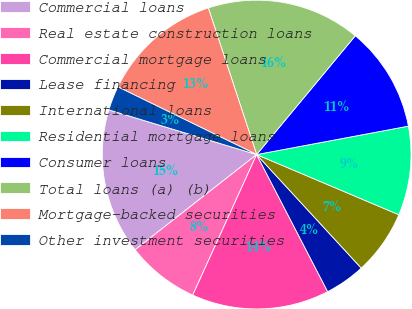Convert chart to OTSL. <chart><loc_0><loc_0><loc_500><loc_500><pie_chart><fcel>Commercial loans<fcel>Real estate construction loans<fcel>Commercial mortgage loans<fcel>Lease financing<fcel>International loans<fcel>Residential mortgage loans<fcel>Consumer loans<fcel>Total loans (a) (b)<fcel>Mortgage-backed securities<fcel>Other investment securities<nl><fcel>15.25%<fcel>7.63%<fcel>14.4%<fcel>4.24%<fcel>6.78%<fcel>9.32%<fcel>11.02%<fcel>16.1%<fcel>12.71%<fcel>2.55%<nl></chart> 